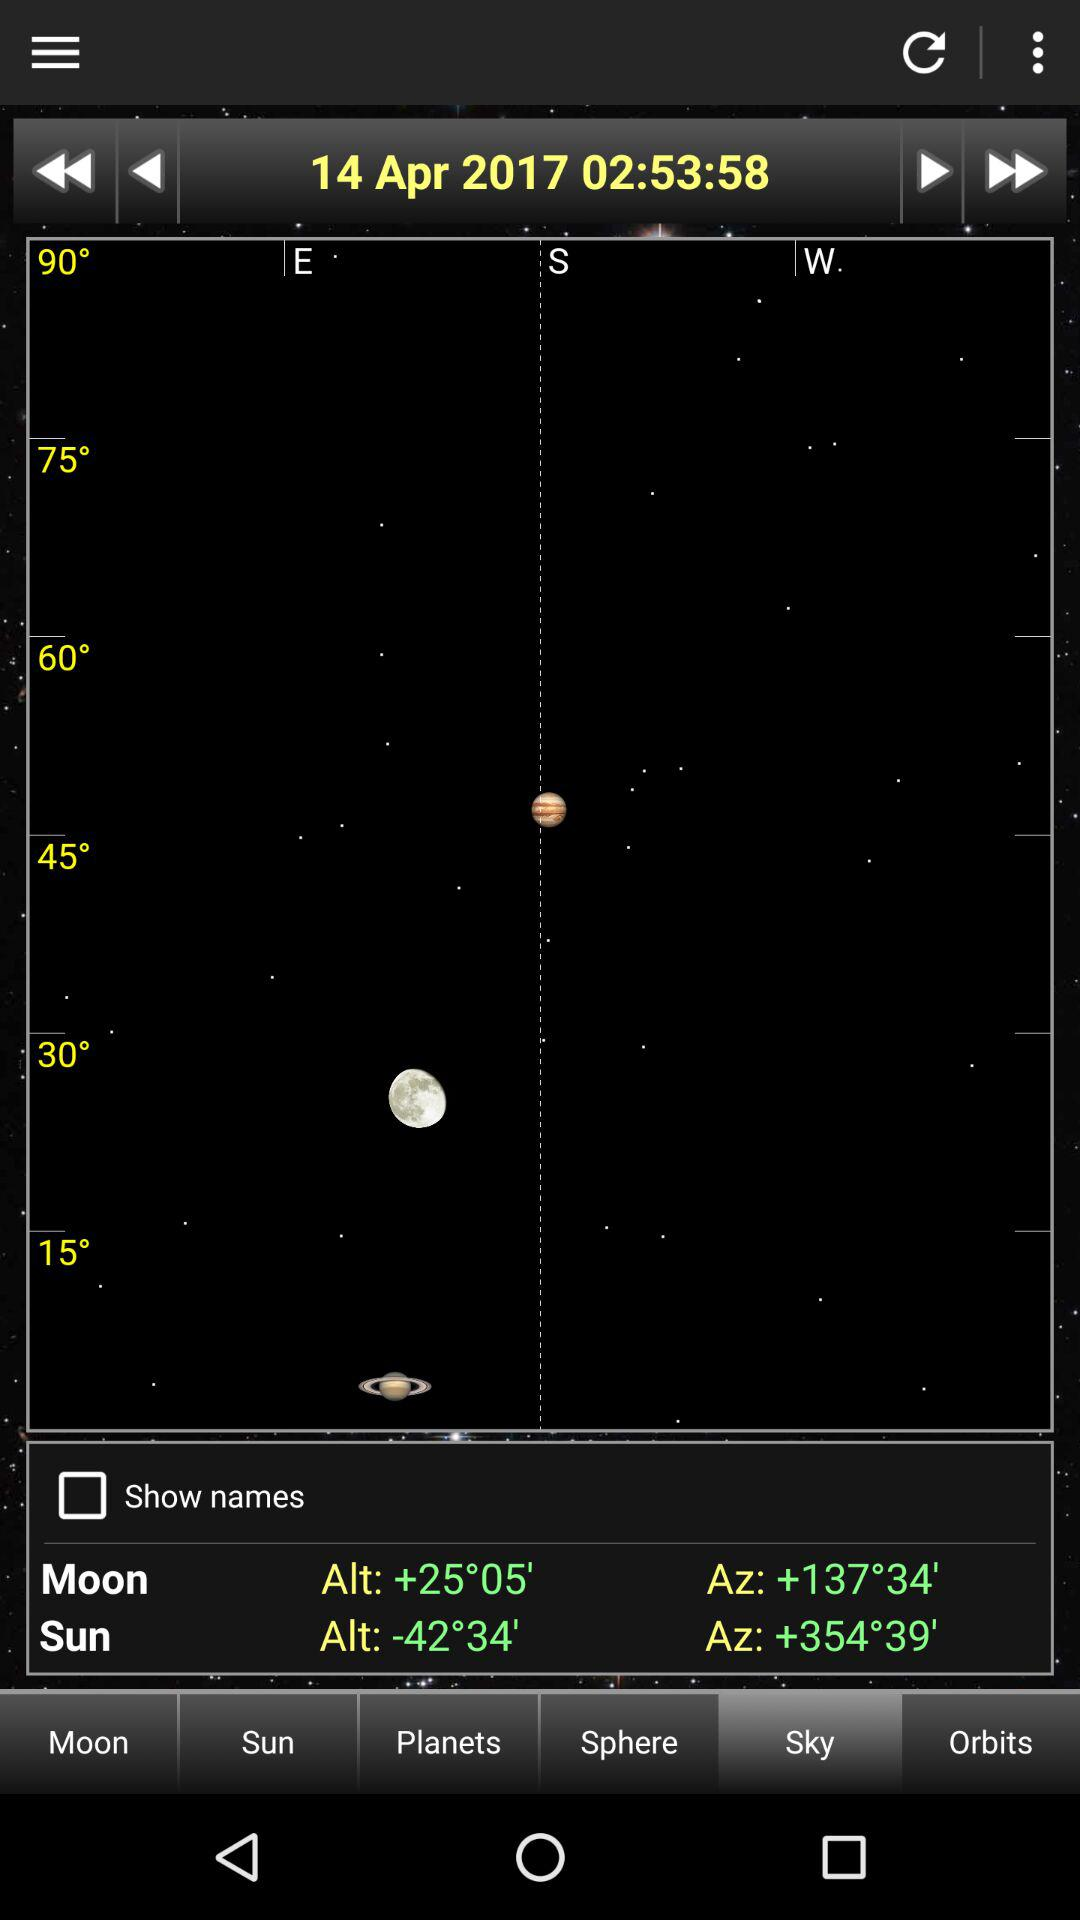What is the moon's altitude value? The moon's altitude value is +25°05'. 